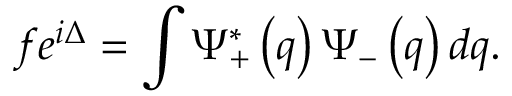<formula> <loc_0><loc_0><loc_500><loc_500>f e ^ { i \Delta } = \int \Psi _ { + } ^ { \ast } \left ( q \right ) \Psi _ { - } \left ( q \right ) d q .</formula> 